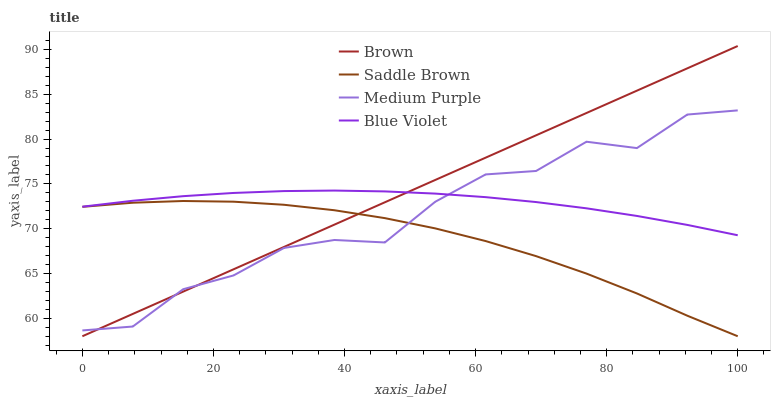Does Saddle Brown have the minimum area under the curve?
Answer yes or no. Yes. Does Brown have the maximum area under the curve?
Answer yes or no. Yes. Does Brown have the minimum area under the curve?
Answer yes or no. No. Does Saddle Brown have the maximum area under the curve?
Answer yes or no. No. Is Brown the smoothest?
Answer yes or no. Yes. Is Medium Purple the roughest?
Answer yes or no. Yes. Is Saddle Brown the smoothest?
Answer yes or no. No. Is Saddle Brown the roughest?
Answer yes or no. No. Does Brown have the lowest value?
Answer yes or no. Yes. Does Blue Violet have the lowest value?
Answer yes or no. No. Does Brown have the highest value?
Answer yes or no. Yes. Does Saddle Brown have the highest value?
Answer yes or no. No. Is Saddle Brown less than Blue Violet?
Answer yes or no. Yes. Is Blue Violet greater than Saddle Brown?
Answer yes or no. Yes. Does Medium Purple intersect Blue Violet?
Answer yes or no. Yes. Is Medium Purple less than Blue Violet?
Answer yes or no. No. Is Medium Purple greater than Blue Violet?
Answer yes or no. No. Does Saddle Brown intersect Blue Violet?
Answer yes or no. No. 